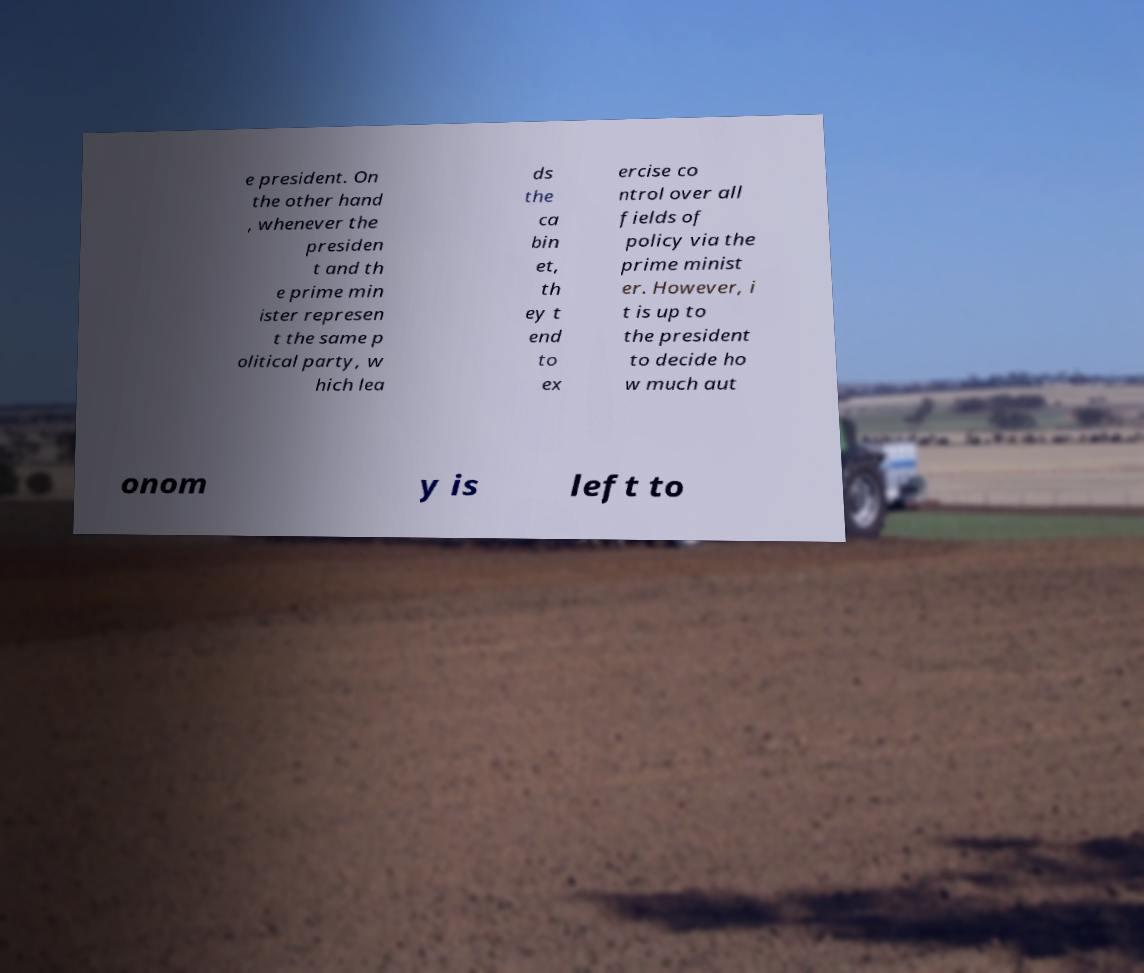I need the written content from this picture converted into text. Can you do that? e president. On the other hand , whenever the presiden t and th e prime min ister represen t the same p olitical party, w hich lea ds the ca bin et, th ey t end to ex ercise co ntrol over all fields of policy via the prime minist er. However, i t is up to the president to decide ho w much aut onom y is left to 